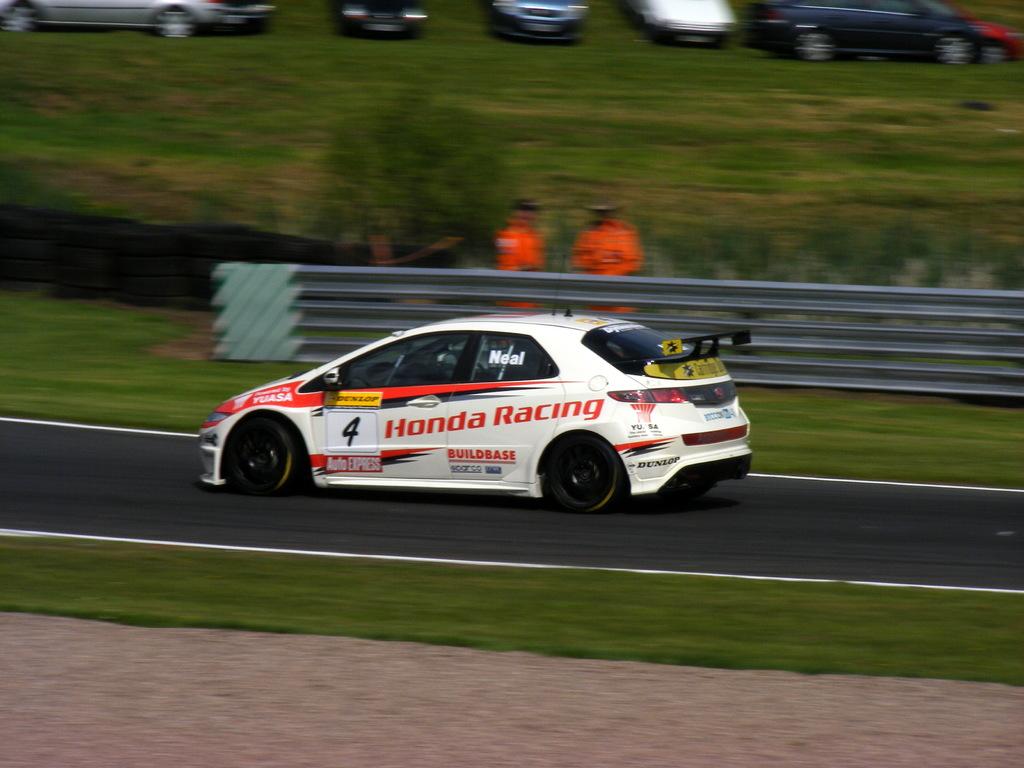What number is the car?
Offer a terse response. 4. 